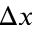<formula> <loc_0><loc_0><loc_500><loc_500>\Delta x</formula> 